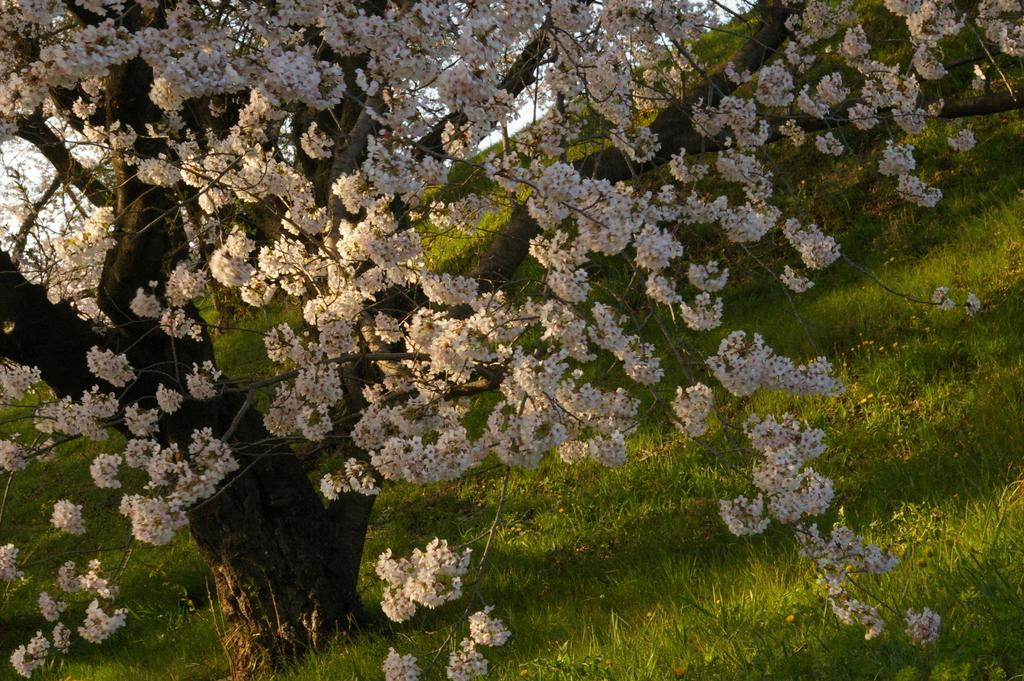What type of plant is featured in the image? There is a flower tree in the image. Where is the flower tree located? The flower tree is on a grassland. What can be seen in the background of the image? The sky is visible in the background of the image. What type of pan is hanging from the roof in the image? There is no pan or roof present in the image; it features a flower tree on a grassland with the sky visible in the background. 